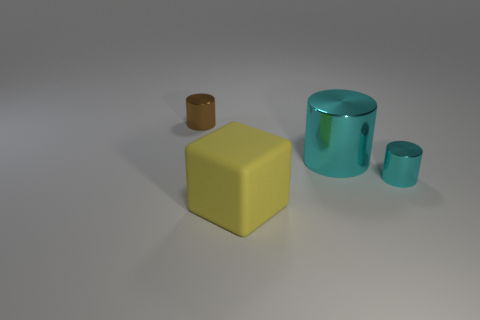Is there anything else that is the same material as the large block?
Make the answer very short. No. What is the shape of the object that is in front of the big cyan cylinder and left of the small cyan shiny cylinder?
Your answer should be very brief. Cube. What color is the metallic cylinder that is in front of the large object that is behind the tiny metal cylinder to the right of the matte block?
Provide a short and direct response. Cyan. Is the number of big yellow objects behind the brown metal cylinder greater than the number of small brown objects to the right of the big cylinder?
Provide a short and direct response. No. What number of other objects are there of the same size as the brown metal cylinder?
Offer a terse response. 1. What is the size of the other metallic object that is the same color as the big metal object?
Provide a succinct answer. Small. The large thing in front of the cyan shiny cylinder that is right of the big cyan metal cylinder is made of what material?
Keep it short and to the point. Rubber. Are there any big shiny cylinders on the left side of the yellow matte object?
Provide a short and direct response. No. Are there more tiny shiny things that are behind the brown metallic thing than large yellow objects?
Keep it short and to the point. No. Is there a tiny rubber object of the same color as the rubber cube?
Offer a terse response. No. 